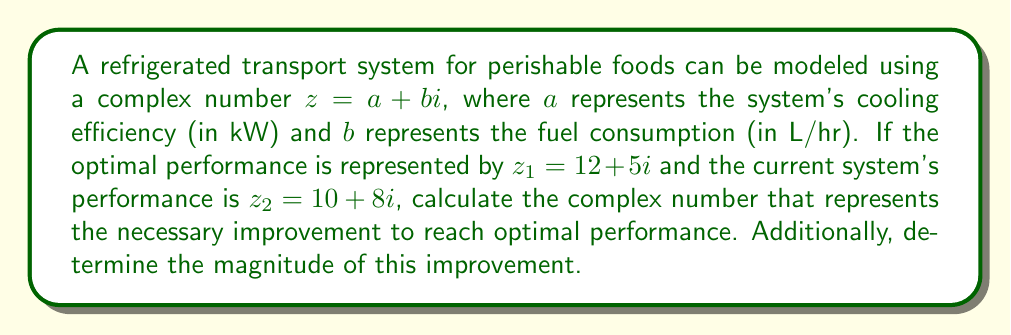Provide a solution to this math problem. To solve this problem, we need to follow these steps:

1) The improvement needed is the difference between the optimal performance and the current performance. In complex number notation, this is represented by $z_1 - z_2$.

2) Subtracting complex numbers:
   $z_1 - z_2 = (12 + 5i) - (10 + 8i)$
   $= (12 - 10) + (5i - 8i)$
   $= 2 - 3i$

3) This result means that the cooling efficiency needs to be improved by 2 kW, while the fuel consumption needs to be reduced by 3 L/hr.

4) To find the magnitude of this improvement, we use the absolute value of a complex number:
   $|z| = \sqrt{a^2 + b^2}$

   Where $z = 2 - 3i$, so $a = 2$ and $b = -3$

   $|z| = \sqrt{2^2 + (-3)^2}$
   $= \sqrt{4 + 9}$
   $= \sqrt{13}$

Therefore, the magnitude of the improvement needed is $\sqrt{13}$ units.
Answer: The complex number representing the necessary improvement is $2 - 3i$, and the magnitude of this improvement is $\sqrt{13}$ units. 